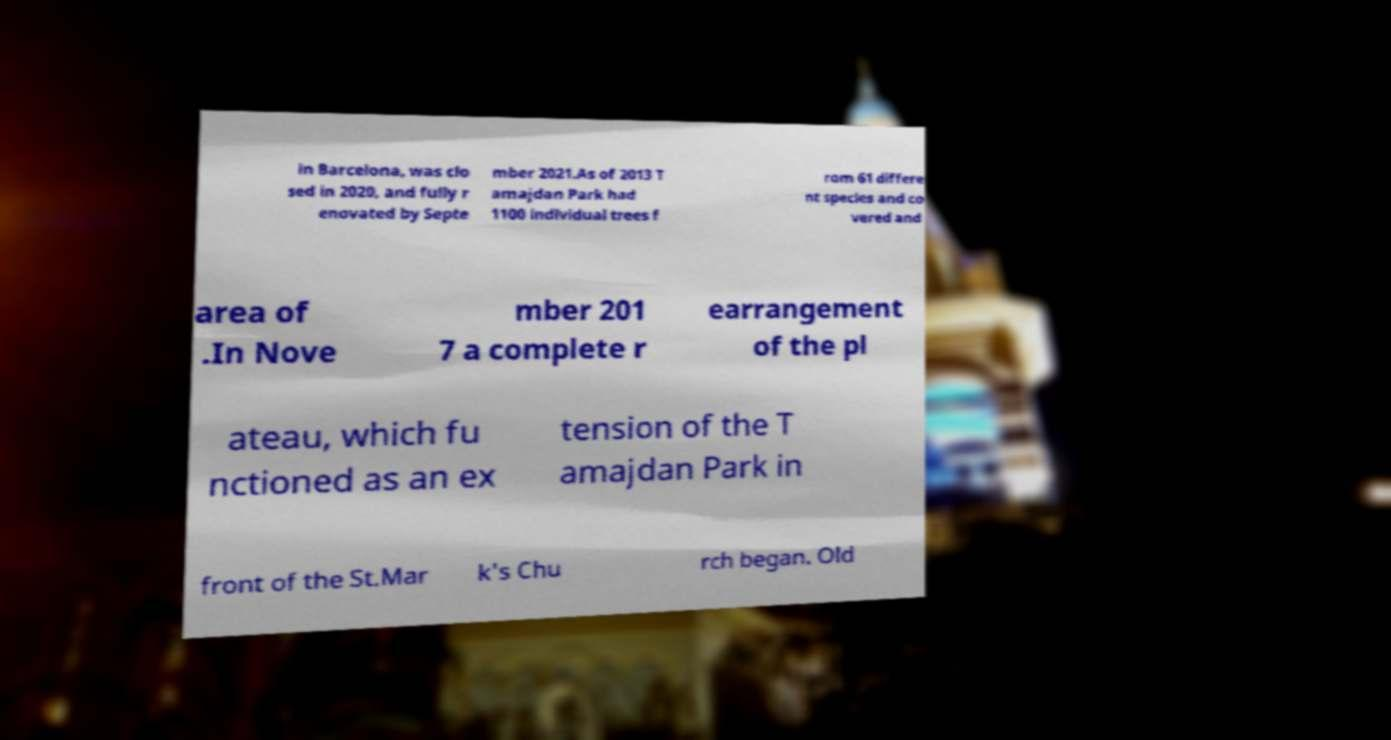There's text embedded in this image that I need extracted. Can you transcribe it verbatim? in Barcelona, was clo sed in 2020, and fully r enovated by Septe mber 2021.As of 2013 T amajdan Park had 1100 individual trees f rom 61 differe nt species and co vered and area of .In Nove mber 201 7 a complete r earrangement of the pl ateau, which fu nctioned as an ex tension of the T amajdan Park in front of the St.Mar k's Chu rch began. Old 